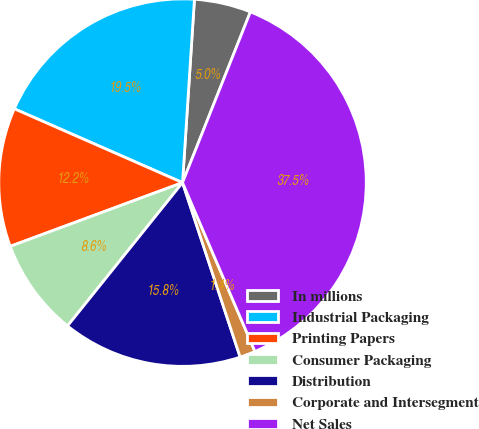<chart> <loc_0><loc_0><loc_500><loc_500><pie_chart><fcel>In millions<fcel>Industrial Packaging<fcel>Printing Papers<fcel>Consumer Packaging<fcel>Distribution<fcel>Corporate and Intersegment<fcel>Net Sales<nl><fcel>4.99%<fcel>19.45%<fcel>12.22%<fcel>8.6%<fcel>15.84%<fcel>1.37%<fcel>37.53%<nl></chart> 